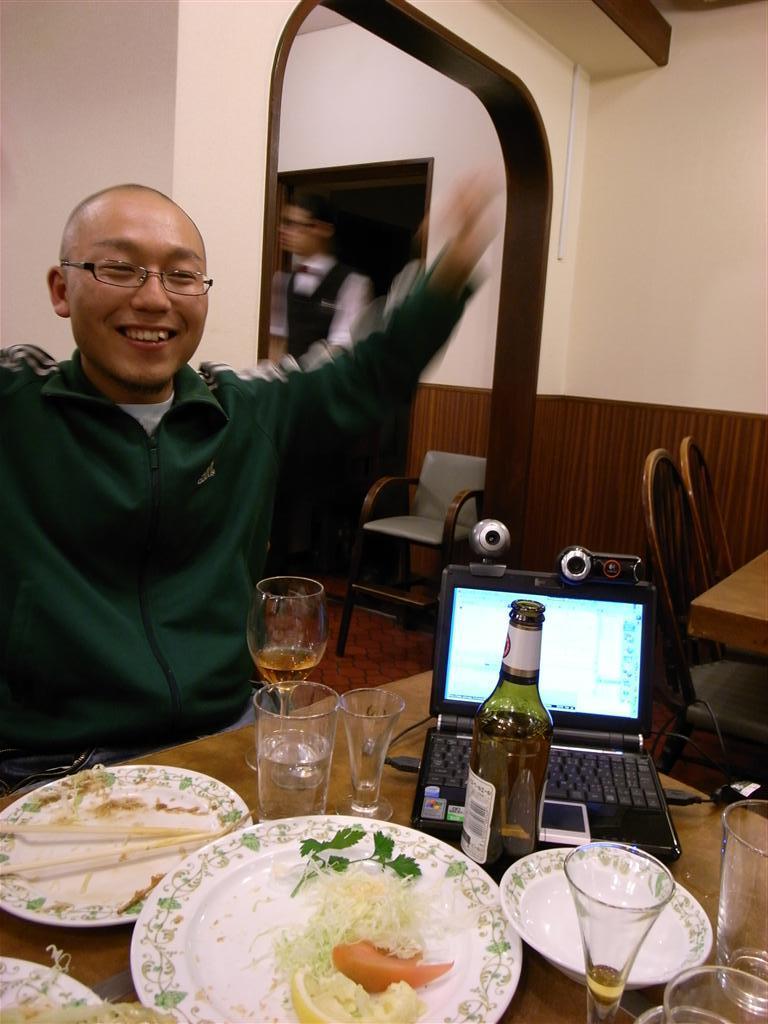Can you describe this image briefly? A person wearing a green coat and spectacles is smiling and sitting on a chair. There is a table in front of him. There are plate, food , glass, bottle and laptop on this table. There is a wall beside him. There are chairs in this room. 